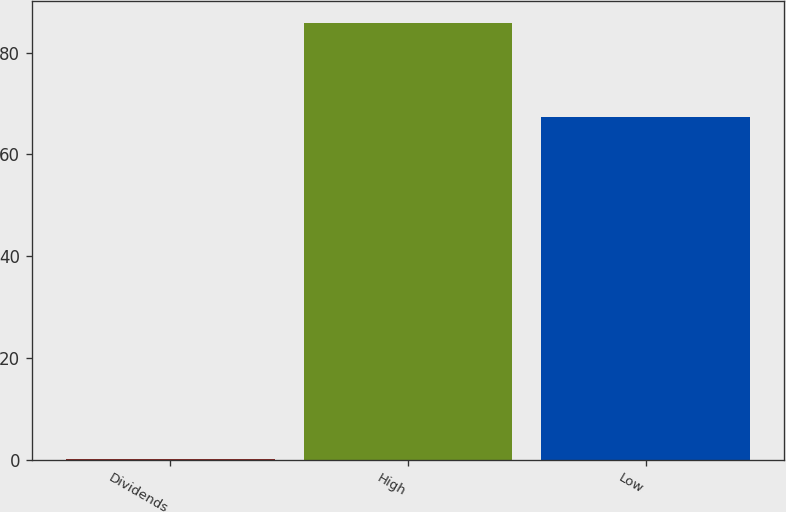<chart> <loc_0><loc_0><loc_500><loc_500><bar_chart><fcel>Dividends<fcel>High<fcel>Low<nl><fcel>0.27<fcel>85.8<fcel>67.34<nl></chart> 